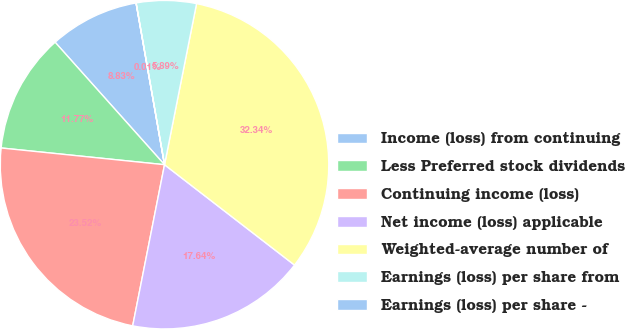Convert chart to OTSL. <chart><loc_0><loc_0><loc_500><loc_500><pie_chart><fcel>Income (loss) from continuing<fcel>Less Preferred stock dividends<fcel>Continuing income (loss)<fcel>Net income (loss) applicable<fcel>Weighted-average number of<fcel>Earnings (loss) per share from<fcel>Earnings (loss) per share -<nl><fcel>8.83%<fcel>11.77%<fcel>23.52%<fcel>17.64%<fcel>32.34%<fcel>5.89%<fcel>0.01%<nl></chart> 